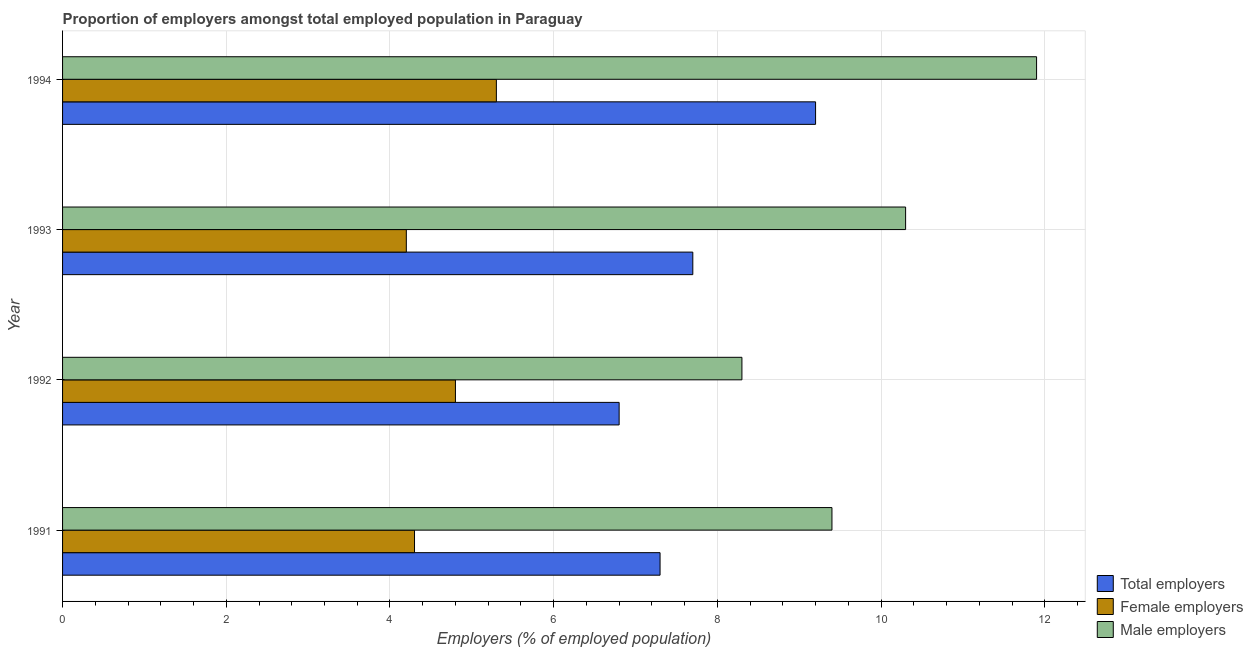How many different coloured bars are there?
Offer a terse response. 3. How many bars are there on the 2nd tick from the bottom?
Give a very brief answer. 3. What is the percentage of total employers in 1991?
Keep it short and to the point. 7.3. Across all years, what is the maximum percentage of female employers?
Offer a terse response. 5.3. Across all years, what is the minimum percentage of male employers?
Provide a succinct answer. 8.3. In which year was the percentage of male employers maximum?
Keep it short and to the point. 1994. In which year was the percentage of female employers minimum?
Your response must be concise. 1993. What is the total percentage of male employers in the graph?
Make the answer very short. 39.9. What is the difference between the percentage of total employers in 1992 and that in 1994?
Keep it short and to the point. -2.4. What is the difference between the percentage of male employers in 1994 and the percentage of total employers in 1992?
Provide a short and direct response. 5.1. What is the average percentage of female employers per year?
Make the answer very short. 4.65. In the year 1994, what is the difference between the percentage of female employers and percentage of male employers?
Give a very brief answer. -6.6. In how many years, is the percentage of female employers greater than 9.6 %?
Your answer should be very brief. 0. What is the ratio of the percentage of male employers in 1991 to that in 1994?
Keep it short and to the point. 0.79. Is the percentage of female employers in 1992 less than that in 1993?
Provide a short and direct response. No. What does the 2nd bar from the top in 1991 represents?
Give a very brief answer. Female employers. What does the 3rd bar from the bottom in 1993 represents?
Your answer should be compact. Male employers. Is it the case that in every year, the sum of the percentage of total employers and percentage of female employers is greater than the percentage of male employers?
Give a very brief answer. Yes. How many years are there in the graph?
Your answer should be very brief. 4. What is the title of the graph?
Offer a terse response. Proportion of employers amongst total employed population in Paraguay. What is the label or title of the X-axis?
Your answer should be compact. Employers (% of employed population). What is the label or title of the Y-axis?
Offer a terse response. Year. What is the Employers (% of employed population) of Total employers in 1991?
Your response must be concise. 7.3. What is the Employers (% of employed population) of Female employers in 1991?
Provide a succinct answer. 4.3. What is the Employers (% of employed population) in Male employers in 1991?
Offer a very short reply. 9.4. What is the Employers (% of employed population) in Total employers in 1992?
Provide a short and direct response. 6.8. What is the Employers (% of employed population) of Female employers in 1992?
Make the answer very short. 4.8. What is the Employers (% of employed population) in Male employers in 1992?
Your answer should be very brief. 8.3. What is the Employers (% of employed population) in Total employers in 1993?
Your response must be concise. 7.7. What is the Employers (% of employed population) of Female employers in 1993?
Keep it short and to the point. 4.2. What is the Employers (% of employed population) of Male employers in 1993?
Provide a succinct answer. 10.3. What is the Employers (% of employed population) of Total employers in 1994?
Your answer should be compact. 9.2. What is the Employers (% of employed population) in Female employers in 1994?
Your answer should be very brief. 5.3. What is the Employers (% of employed population) in Male employers in 1994?
Provide a short and direct response. 11.9. Across all years, what is the maximum Employers (% of employed population) of Total employers?
Ensure brevity in your answer.  9.2. Across all years, what is the maximum Employers (% of employed population) of Female employers?
Keep it short and to the point. 5.3. Across all years, what is the maximum Employers (% of employed population) of Male employers?
Give a very brief answer. 11.9. Across all years, what is the minimum Employers (% of employed population) in Total employers?
Give a very brief answer. 6.8. Across all years, what is the minimum Employers (% of employed population) in Female employers?
Make the answer very short. 4.2. Across all years, what is the minimum Employers (% of employed population) in Male employers?
Offer a very short reply. 8.3. What is the total Employers (% of employed population) in Total employers in the graph?
Your response must be concise. 31. What is the total Employers (% of employed population) of Male employers in the graph?
Offer a terse response. 39.9. What is the difference between the Employers (% of employed population) in Female employers in 1991 and that in 1992?
Make the answer very short. -0.5. What is the difference between the Employers (% of employed population) in Total employers in 1991 and that in 1993?
Your answer should be compact. -0.4. What is the difference between the Employers (% of employed population) of Female employers in 1991 and that in 1994?
Provide a short and direct response. -1. What is the difference between the Employers (% of employed population) of Male employers in 1991 and that in 1994?
Provide a short and direct response. -2.5. What is the difference between the Employers (% of employed population) of Total employers in 1992 and that in 1993?
Your answer should be very brief. -0.9. What is the difference between the Employers (% of employed population) in Female employers in 1992 and that in 1993?
Give a very brief answer. 0.6. What is the difference between the Employers (% of employed population) of Male employers in 1992 and that in 1993?
Your response must be concise. -2. What is the difference between the Employers (% of employed population) in Female employers in 1992 and that in 1994?
Provide a short and direct response. -0.5. What is the difference between the Employers (% of employed population) of Male employers in 1992 and that in 1994?
Give a very brief answer. -3.6. What is the difference between the Employers (% of employed population) in Male employers in 1993 and that in 1994?
Offer a terse response. -1.6. What is the difference between the Employers (% of employed population) in Total employers in 1991 and the Employers (% of employed population) in Male employers in 1992?
Ensure brevity in your answer.  -1. What is the difference between the Employers (% of employed population) in Total employers in 1991 and the Employers (% of employed population) in Male employers in 1993?
Provide a short and direct response. -3. What is the difference between the Employers (% of employed population) of Total employers in 1991 and the Employers (% of employed population) of Male employers in 1994?
Make the answer very short. -4.6. What is the difference between the Employers (% of employed population) in Female employers in 1992 and the Employers (% of employed population) in Male employers in 1993?
Offer a very short reply. -5.5. What is the difference between the Employers (% of employed population) of Total employers in 1992 and the Employers (% of employed population) of Male employers in 1994?
Your answer should be compact. -5.1. What is the difference between the Employers (% of employed population) of Total employers in 1993 and the Employers (% of employed population) of Female employers in 1994?
Make the answer very short. 2.4. What is the difference between the Employers (% of employed population) in Female employers in 1993 and the Employers (% of employed population) in Male employers in 1994?
Give a very brief answer. -7.7. What is the average Employers (% of employed population) of Total employers per year?
Provide a succinct answer. 7.75. What is the average Employers (% of employed population) in Female employers per year?
Give a very brief answer. 4.65. What is the average Employers (% of employed population) in Male employers per year?
Your response must be concise. 9.97. In the year 1992, what is the difference between the Employers (% of employed population) of Total employers and Employers (% of employed population) of Female employers?
Ensure brevity in your answer.  2. In the year 1992, what is the difference between the Employers (% of employed population) in Total employers and Employers (% of employed population) in Male employers?
Your answer should be compact. -1.5. In the year 1993, what is the difference between the Employers (% of employed population) of Total employers and Employers (% of employed population) of Female employers?
Your answer should be compact. 3.5. In the year 1993, what is the difference between the Employers (% of employed population) of Total employers and Employers (% of employed population) of Male employers?
Make the answer very short. -2.6. In the year 1993, what is the difference between the Employers (% of employed population) in Female employers and Employers (% of employed population) in Male employers?
Your answer should be compact. -6.1. What is the ratio of the Employers (% of employed population) of Total employers in 1991 to that in 1992?
Provide a short and direct response. 1.07. What is the ratio of the Employers (% of employed population) of Female employers in 1991 to that in 1992?
Make the answer very short. 0.9. What is the ratio of the Employers (% of employed population) of Male employers in 1991 to that in 1992?
Keep it short and to the point. 1.13. What is the ratio of the Employers (% of employed population) of Total employers in 1991 to that in 1993?
Offer a terse response. 0.95. What is the ratio of the Employers (% of employed population) in Female employers in 1991 to that in 1993?
Provide a short and direct response. 1.02. What is the ratio of the Employers (% of employed population) in Male employers in 1991 to that in 1993?
Provide a succinct answer. 0.91. What is the ratio of the Employers (% of employed population) in Total employers in 1991 to that in 1994?
Ensure brevity in your answer.  0.79. What is the ratio of the Employers (% of employed population) of Female employers in 1991 to that in 1994?
Offer a very short reply. 0.81. What is the ratio of the Employers (% of employed population) in Male employers in 1991 to that in 1994?
Offer a very short reply. 0.79. What is the ratio of the Employers (% of employed population) of Total employers in 1992 to that in 1993?
Offer a very short reply. 0.88. What is the ratio of the Employers (% of employed population) in Male employers in 1992 to that in 1993?
Keep it short and to the point. 0.81. What is the ratio of the Employers (% of employed population) in Total employers in 1992 to that in 1994?
Keep it short and to the point. 0.74. What is the ratio of the Employers (% of employed population) of Female employers in 1992 to that in 1994?
Give a very brief answer. 0.91. What is the ratio of the Employers (% of employed population) in Male employers in 1992 to that in 1994?
Ensure brevity in your answer.  0.7. What is the ratio of the Employers (% of employed population) in Total employers in 1993 to that in 1994?
Provide a succinct answer. 0.84. What is the ratio of the Employers (% of employed population) of Female employers in 1993 to that in 1994?
Your answer should be very brief. 0.79. What is the ratio of the Employers (% of employed population) of Male employers in 1993 to that in 1994?
Give a very brief answer. 0.87. What is the difference between the highest and the second highest Employers (% of employed population) in Total employers?
Ensure brevity in your answer.  1.5. What is the difference between the highest and the second highest Employers (% of employed population) in Female employers?
Your answer should be compact. 0.5. What is the difference between the highest and the lowest Employers (% of employed population) in Female employers?
Offer a terse response. 1.1. 